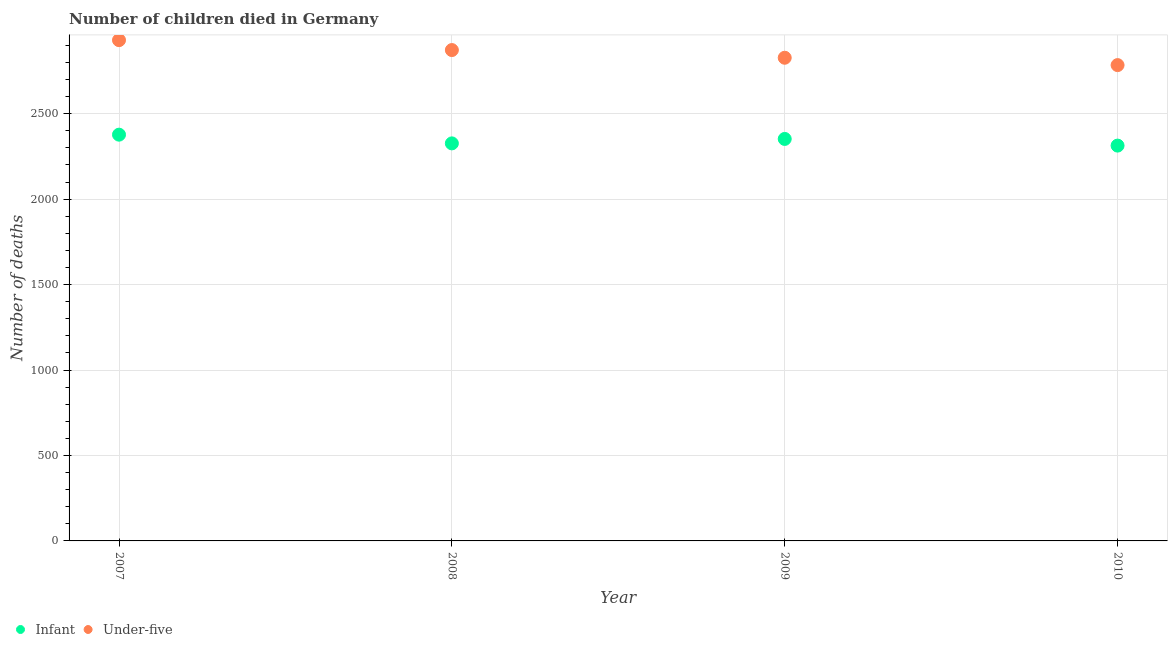How many different coloured dotlines are there?
Keep it short and to the point. 2. Is the number of dotlines equal to the number of legend labels?
Your answer should be very brief. Yes. What is the number of under-five deaths in 2009?
Give a very brief answer. 2827. Across all years, what is the maximum number of under-five deaths?
Keep it short and to the point. 2930. Across all years, what is the minimum number of infant deaths?
Make the answer very short. 2313. What is the total number of infant deaths in the graph?
Ensure brevity in your answer.  9368. What is the difference between the number of under-five deaths in 2007 and that in 2009?
Your answer should be compact. 103. What is the difference between the number of infant deaths in 2007 and the number of under-five deaths in 2010?
Provide a succinct answer. -407. What is the average number of under-five deaths per year?
Provide a short and direct response. 2853.25. In the year 2008, what is the difference between the number of infant deaths and number of under-five deaths?
Provide a succinct answer. -546. What is the ratio of the number of under-five deaths in 2008 to that in 2010?
Provide a succinct answer. 1.03. What is the difference between the highest and the second highest number of infant deaths?
Provide a short and direct response. 25. What is the difference between the highest and the lowest number of under-five deaths?
Ensure brevity in your answer.  146. In how many years, is the number of under-five deaths greater than the average number of under-five deaths taken over all years?
Provide a succinct answer. 2. Is the sum of the number of infant deaths in 2008 and 2010 greater than the maximum number of under-five deaths across all years?
Ensure brevity in your answer.  Yes. Does the number of under-five deaths monotonically increase over the years?
Your response must be concise. No. How many dotlines are there?
Keep it short and to the point. 2. How many years are there in the graph?
Your answer should be very brief. 4. What is the title of the graph?
Your response must be concise. Number of children died in Germany. What is the label or title of the Y-axis?
Keep it short and to the point. Number of deaths. What is the Number of deaths of Infant in 2007?
Provide a succinct answer. 2377. What is the Number of deaths of Under-five in 2007?
Make the answer very short. 2930. What is the Number of deaths of Infant in 2008?
Offer a terse response. 2326. What is the Number of deaths of Under-five in 2008?
Offer a terse response. 2872. What is the Number of deaths of Infant in 2009?
Offer a terse response. 2352. What is the Number of deaths in Under-five in 2009?
Your answer should be compact. 2827. What is the Number of deaths of Infant in 2010?
Ensure brevity in your answer.  2313. What is the Number of deaths of Under-five in 2010?
Offer a terse response. 2784. Across all years, what is the maximum Number of deaths in Infant?
Offer a terse response. 2377. Across all years, what is the maximum Number of deaths of Under-five?
Offer a terse response. 2930. Across all years, what is the minimum Number of deaths of Infant?
Offer a very short reply. 2313. Across all years, what is the minimum Number of deaths of Under-five?
Your response must be concise. 2784. What is the total Number of deaths of Infant in the graph?
Your answer should be very brief. 9368. What is the total Number of deaths in Under-five in the graph?
Your response must be concise. 1.14e+04. What is the difference between the Number of deaths of Infant in 2007 and that in 2009?
Ensure brevity in your answer.  25. What is the difference between the Number of deaths in Under-five in 2007 and that in 2009?
Provide a short and direct response. 103. What is the difference between the Number of deaths of Under-five in 2007 and that in 2010?
Ensure brevity in your answer.  146. What is the difference between the Number of deaths of Under-five in 2008 and that in 2009?
Give a very brief answer. 45. What is the difference between the Number of deaths in Infant in 2008 and that in 2010?
Provide a short and direct response. 13. What is the difference between the Number of deaths in Infant in 2009 and that in 2010?
Offer a terse response. 39. What is the difference between the Number of deaths in Under-five in 2009 and that in 2010?
Give a very brief answer. 43. What is the difference between the Number of deaths of Infant in 2007 and the Number of deaths of Under-five in 2008?
Offer a terse response. -495. What is the difference between the Number of deaths of Infant in 2007 and the Number of deaths of Under-five in 2009?
Keep it short and to the point. -450. What is the difference between the Number of deaths in Infant in 2007 and the Number of deaths in Under-five in 2010?
Provide a succinct answer. -407. What is the difference between the Number of deaths in Infant in 2008 and the Number of deaths in Under-five in 2009?
Provide a succinct answer. -501. What is the difference between the Number of deaths of Infant in 2008 and the Number of deaths of Under-five in 2010?
Your answer should be compact. -458. What is the difference between the Number of deaths in Infant in 2009 and the Number of deaths in Under-five in 2010?
Offer a very short reply. -432. What is the average Number of deaths in Infant per year?
Make the answer very short. 2342. What is the average Number of deaths of Under-five per year?
Give a very brief answer. 2853.25. In the year 2007, what is the difference between the Number of deaths of Infant and Number of deaths of Under-five?
Provide a succinct answer. -553. In the year 2008, what is the difference between the Number of deaths of Infant and Number of deaths of Under-five?
Offer a terse response. -546. In the year 2009, what is the difference between the Number of deaths in Infant and Number of deaths in Under-five?
Make the answer very short. -475. In the year 2010, what is the difference between the Number of deaths of Infant and Number of deaths of Under-five?
Give a very brief answer. -471. What is the ratio of the Number of deaths of Infant in 2007 to that in 2008?
Offer a terse response. 1.02. What is the ratio of the Number of deaths of Under-five in 2007 to that in 2008?
Ensure brevity in your answer.  1.02. What is the ratio of the Number of deaths of Infant in 2007 to that in 2009?
Provide a succinct answer. 1.01. What is the ratio of the Number of deaths of Under-five in 2007 to that in 2009?
Give a very brief answer. 1.04. What is the ratio of the Number of deaths of Infant in 2007 to that in 2010?
Your answer should be compact. 1.03. What is the ratio of the Number of deaths in Under-five in 2007 to that in 2010?
Your answer should be very brief. 1.05. What is the ratio of the Number of deaths of Infant in 2008 to that in 2009?
Provide a succinct answer. 0.99. What is the ratio of the Number of deaths of Under-five in 2008 to that in 2009?
Give a very brief answer. 1.02. What is the ratio of the Number of deaths of Infant in 2008 to that in 2010?
Keep it short and to the point. 1.01. What is the ratio of the Number of deaths of Under-five in 2008 to that in 2010?
Make the answer very short. 1.03. What is the ratio of the Number of deaths in Infant in 2009 to that in 2010?
Offer a very short reply. 1.02. What is the ratio of the Number of deaths of Under-five in 2009 to that in 2010?
Provide a short and direct response. 1.02. What is the difference between the highest and the second highest Number of deaths of Infant?
Your answer should be compact. 25. What is the difference between the highest and the second highest Number of deaths of Under-five?
Offer a terse response. 58. What is the difference between the highest and the lowest Number of deaths of Under-five?
Your answer should be compact. 146. 